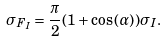<formula> <loc_0><loc_0><loc_500><loc_500>\sigma _ { F _ { I } } = \frac { \pi } { 2 } ( 1 + \cos { ( \alpha ) } ) \sigma _ { I } .</formula> 